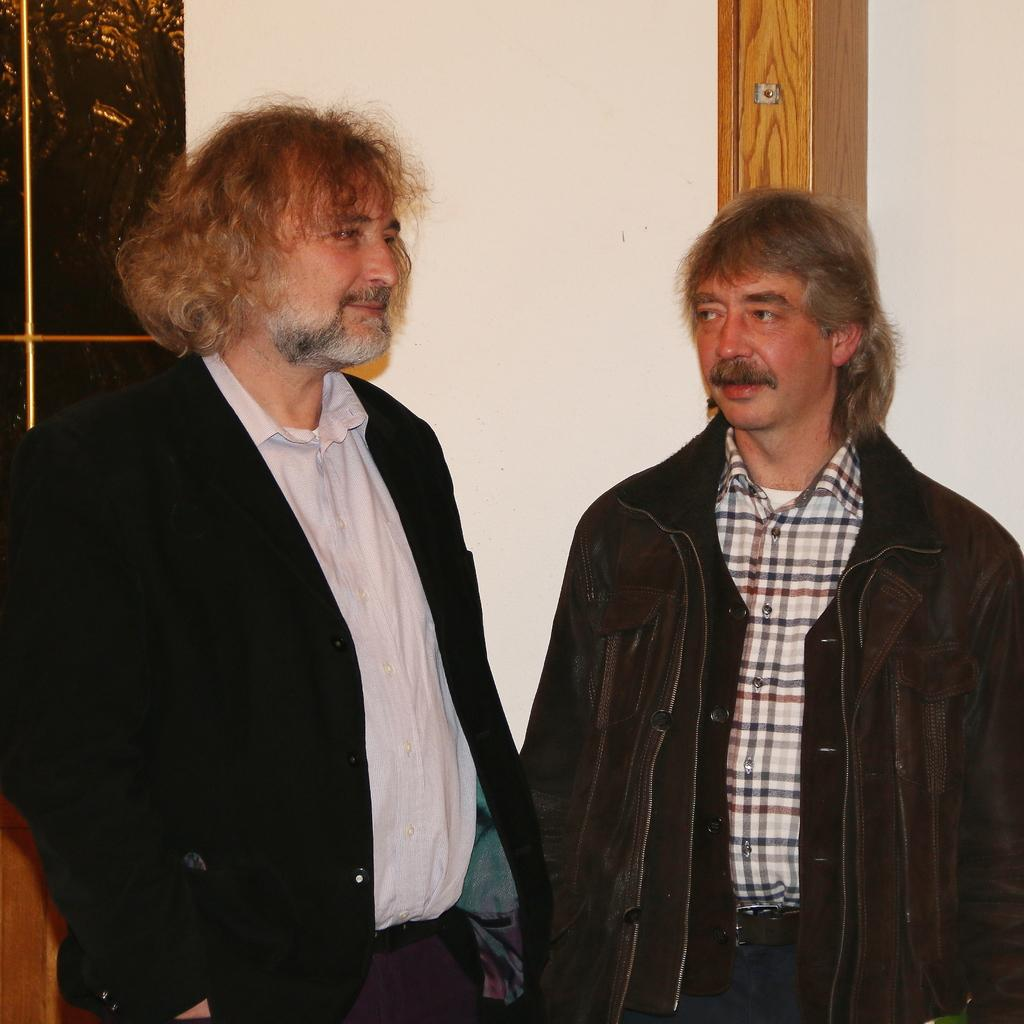How many people are in the image? There are a few people in the image. What can be seen in the background of the image? There is a wall in the background of the image. What is on the wall? There are objects on the wall. What material is visible in the bottom left corner of the image? There is wood visible in the bottom left corner of the image. What type of linen is being used to cover the argument in the image? There is no linen or argument present in the image. What kind of bait is being used to attract the people in the image? There is no bait present in the image; the people are not being attracted by any specific object or action. 